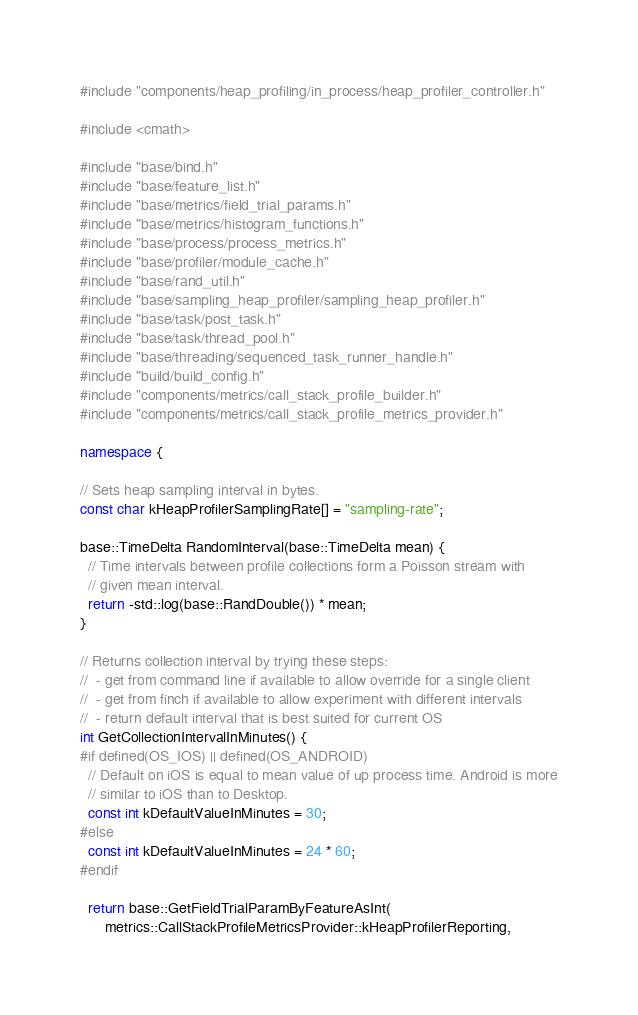Convert code to text. <code><loc_0><loc_0><loc_500><loc_500><_C++_>#include "components/heap_profiling/in_process/heap_profiler_controller.h"

#include <cmath>

#include "base/bind.h"
#include "base/feature_list.h"
#include "base/metrics/field_trial_params.h"
#include "base/metrics/histogram_functions.h"
#include "base/process/process_metrics.h"
#include "base/profiler/module_cache.h"
#include "base/rand_util.h"
#include "base/sampling_heap_profiler/sampling_heap_profiler.h"
#include "base/task/post_task.h"
#include "base/task/thread_pool.h"
#include "base/threading/sequenced_task_runner_handle.h"
#include "build/build_config.h"
#include "components/metrics/call_stack_profile_builder.h"
#include "components/metrics/call_stack_profile_metrics_provider.h"

namespace {

// Sets heap sampling interval in bytes.
const char kHeapProfilerSamplingRate[] = "sampling-rate";

base::TimeDelta RandomInterval(base::TimeDelta mean) {
  // Time intervals between profile collections form a Poisson stream with
  // given mean interval.
  return -std::log(base::RandDouble()) * mean;
}

// Returns collection interval by trying these steps:
//  - get from command line if available to allow override for a single client
//  - get from finch if available to allow experiment with different intervals
//  - return default interval that is best suited for current OS
int GetCollectionIntervalInMinutes() {
#if defined(OS_IOS) || defined(OS_ANDROID)
  // Default on iOS is equal to mean value of up process time. Android is more
  // similar to iOS than to Desktop.
  const int kDefaultValueInMinutes = 30;
#else
  const int kDefaultValueInMinutes = 24 * 60;
#endif

  return base::GetFieldTrialParamByFeatureAsInt(
      metrics::CallStackProfileMetricsProvider::kHeapProfilerReporting,</code> 